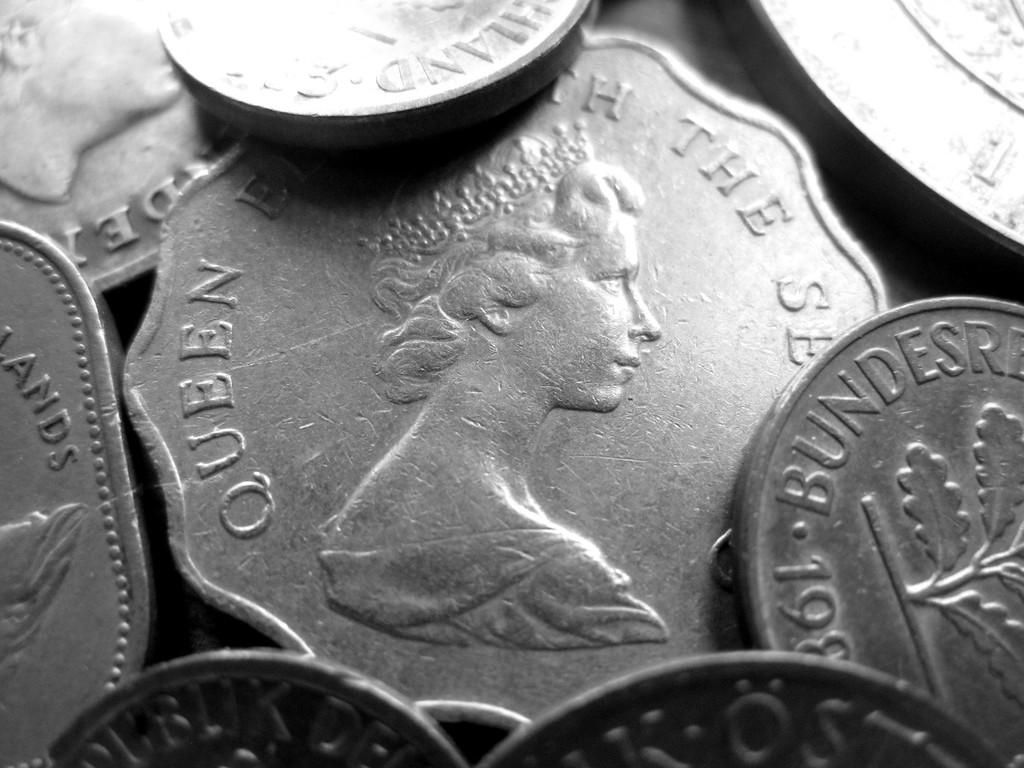<image>
Describe the image concisely. A Queen Elizabeth coin in the center of a pile of silver coins. 